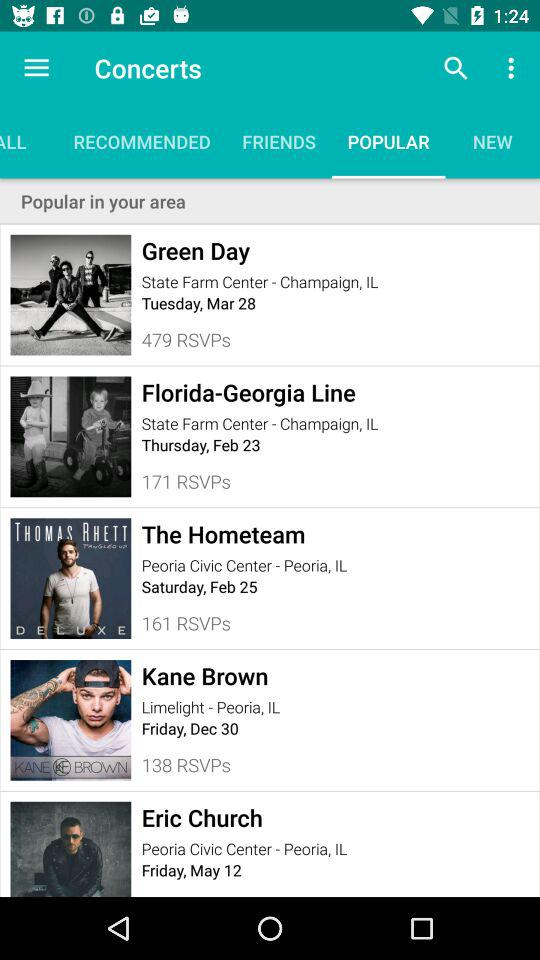What is the location of the "Florida - Georgia Line"? The location of the "Florida - Georgia Line" is "State Farm Center" in Champaign, IL. 